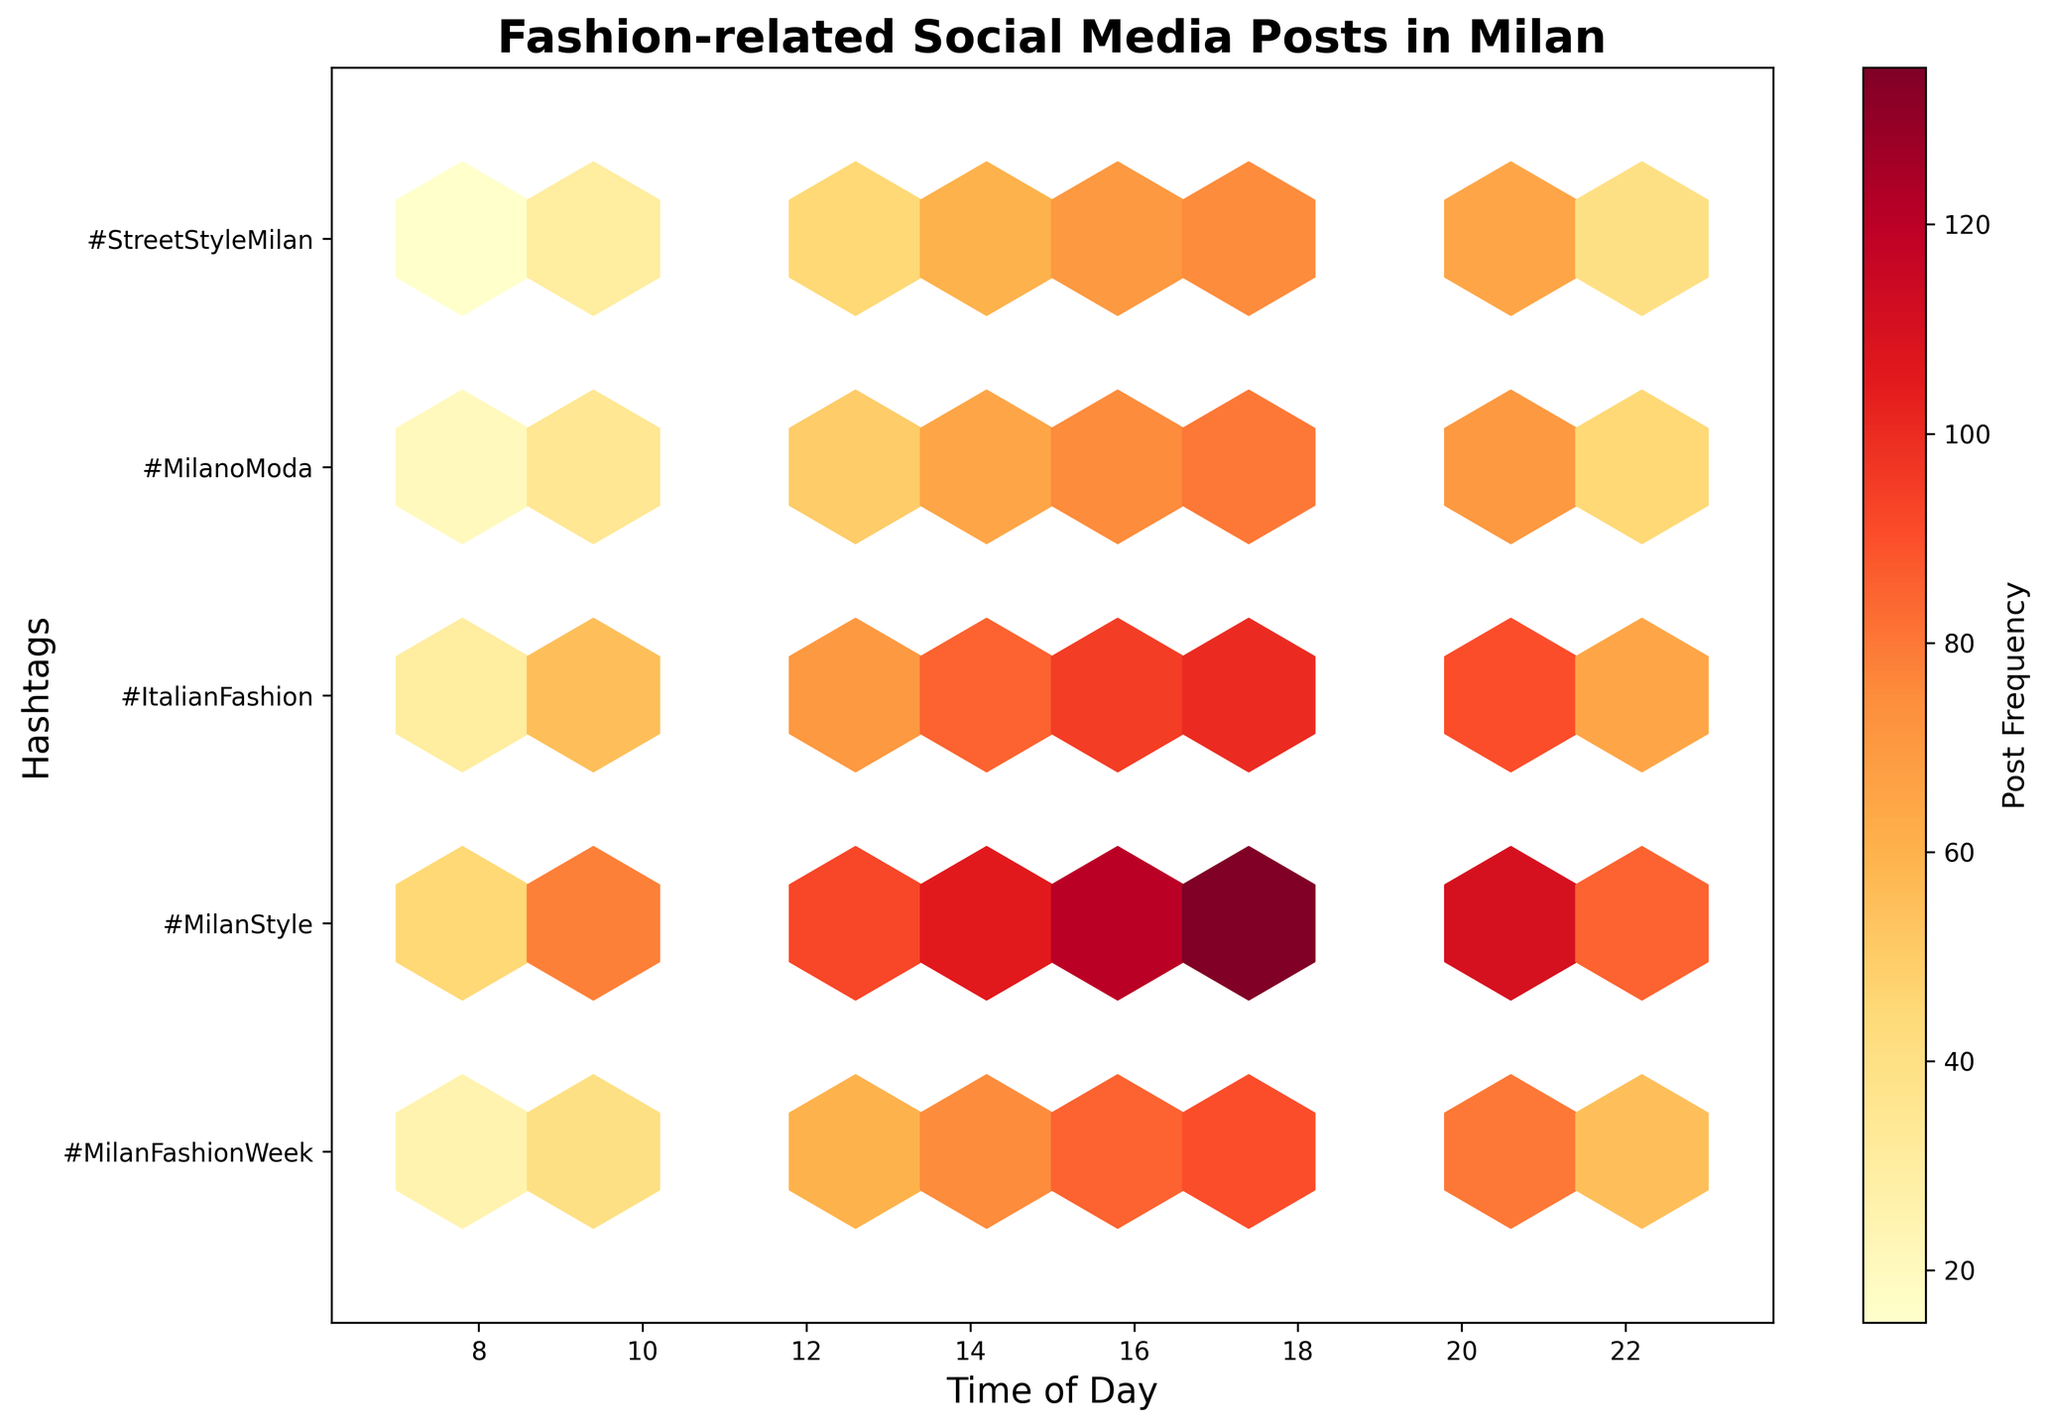What is the title of the plot? The title is displayed at the top of the plot. In this case, it reads "Fashion-related Social Media Posts in Milan".
Answer: Fashion-related Social Media Posts in Milan Which time of day has the highest post frequency for the hashtag #MilanFashionWeek? Looking at the vertical position corresponding to #MilanFashionWeek and scanning horizontally, the highest color density occurs at 18:00.
Answer: 18:00 Which hashtag has the fewest posts around noon (12:00)? Compare the color intensity of the hexagons at noon for each hashtag. #StreetStyleMilan has the least intense color at 12:00.
Answer: #StreetStyleMilan At what time of day does the hashtag #MilanStyle have the highest frequency? Find the row corresponding to #MilanStyle and identify the time of the darkest-colored hexagon. It is at 18:00.
Answer: 18:00 How does the post frequency of #MilanFashionWeek at 14:00 compare to that at 20:00? Check the color density representing the post frequency for #MilanFashionWeek at both 14:00 and 20:00. 14:00 has higher density than 20:00.
Answer: Higher at 14:00 What is the range of time with significant post activity for the hashtag #MilanoModa? Trace the row corresponding to #MilanoModa and identify the range of times with non-light color hexagons. Significant activity is from 10:00 to 20:00.
Answer: 10:00 to 20:00 Is there a time when the post frequencies for all hashtags are relatively low? Look for a vertical band where the color density is light across all rows. The time around 8:00 has relatively low post frequencies for all hashtags.
Answer: 8:00 Which hashtags have peaks at 16:00? Examine the rows at the column corresponding to 16:00. The hashtags #MilanFashionWeek, #MilanStyle, and #ItalianFashion all show dark hexagons at 16:00 indicating peaks.
Answer: #MilanFashionWeek, #MilanStyle, #ItalianFashion What's the average peak time for hashtags based on the plot? Identify the peak times for individual hashtags and calculate the average. Peak times: #MilanFashionWeek (18:00), #MilanStyle (18:00), #ItalianFashion (18:00), #MilanoModa (18:00), #StreetStyleMilan (18:00). The average is then the same 18:00.
Answer: 18:00 